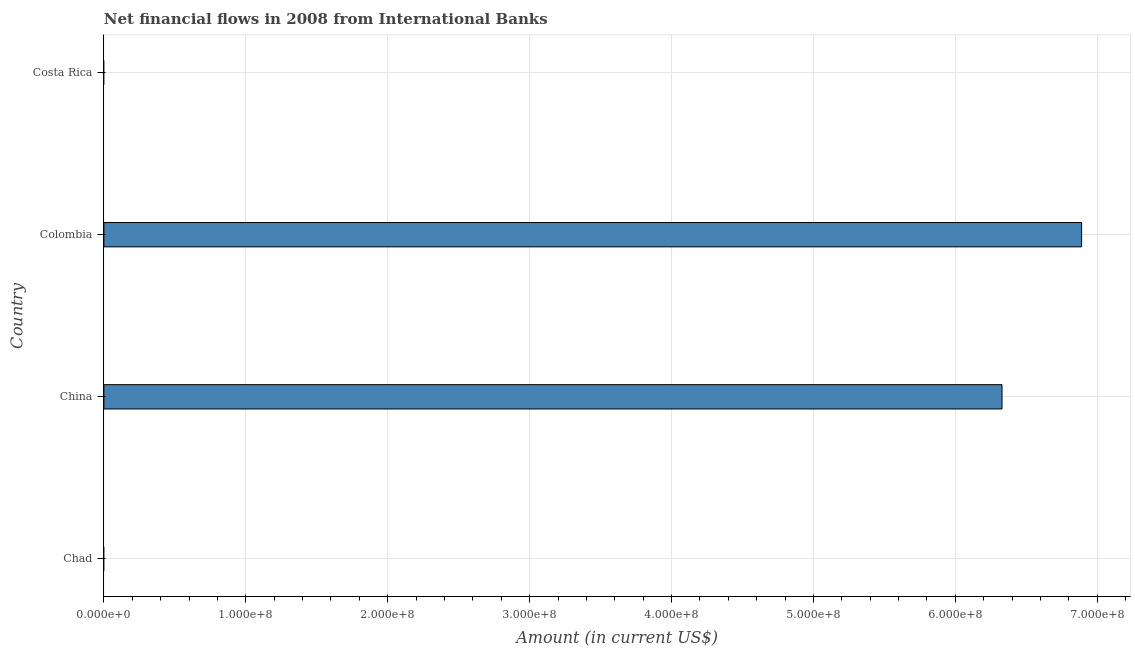Does the graph contain grids?
Your answer should be very brief. Yes. What is the title of the graph?
Your answer should be very brief. Net financial flows in 2008 from International Banks. What is the label or title of the X-axis?
Your answer should be very brief. Amount (in current US$). What is the net financial flows from ibrd in Chad?
Your answer should be very brief. 0. Across all countries, what is the maximum net financial flows from ibrd?
Provide a short and direct response. 6.89e+08. Across all countries, what is the minimum net financial flows from ibrd?
Your answer should be very brief. 0. In which country was the net financial flows from ibrd maximum?
Provide a succinct answer. Colombia. What is the sum of the net financial flows from ibrd?
Ensure brevity in your answer.  1.32e+09. What is the difference between the net financial flows from ibrd in China and Colombia?
Your answer should be compact. -5.61e+07. What is the average net financial flows from ibrd per country?
Your answer should be compact. 3.30e+08. What is the median net financial flows from ibrd?
Offer a terse response. 3.16e+08. What is the ratio of the net financial flows from ibrd in China to that in Colombia?
Give a very brief answer. 0.92. Is the difference between the net financial flows from ibrd in China and Colombia greater than the difference between any two countries?
Provide a short and direct response. No. What is the difference between the highest and the lowest net financial flows from ibrd?
Your answer should be very brief. 6.89e+08. How many bars are there?
Your answer should be very brief. 2. Are all the bars in the graph horizontal?
Your answer should be compact. Yes. What is the difference between two consecutive major ticks on the X-axis?
Provide a short and direct response. 1.00e+08. What is the Amount (in current US$) in Chad?
Offer a very short reply. 0. What is the Amount (in current US$) of China?
Give a very brief answer. 6.33e+08. What is the Amount (in current US$) of Colombia?
Your answer should be very brief. 6.89e+08. What is the Amount (in current US$) in Costa Rica?
Your answer should be very brief. 0. What is the difference between the Amount (in current US$) in China and Colombia?
Provide a succinct answer. -5.61e+07. What is the ratio of the Amount (in current US$) in China to that in Colombia?
Ensure brevity in your answer.  0.92. 